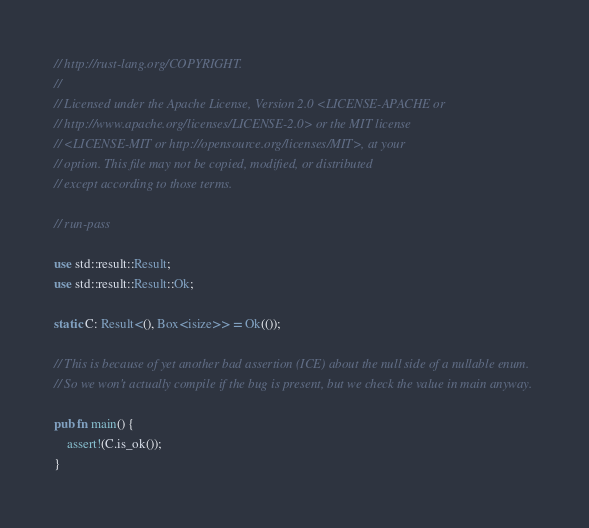Convert code to text. <code><loc_0><loc_0><loc_500><loc_500><_Rust_>// http://rust-lang.org/COPYRIGHT.
//
// Licensed under the Apache License, Version 2.0 <LICENSE-APACHE or
// http://www.apache.org/licenses/LICENSE-2.0> or the MIT license
// <LICENSE-MIT or http://opensource.org/licenses/MIT>, at your
// option. This file may not be copied, modified, or distributed
// except according to those terms.

// run-pass

use std::result::Result;
use std::result::Result::Ok;

static C: Result<(), Box<isize>> = Ok(());

// This is because of yet another bad assertion (ICE) about the null side of a nullable enum.
// So we won't actually compile if the bug is present, but we check the value in main anyway.

pub fn main() {
    assert!(C.is_ok());
}
</code> 